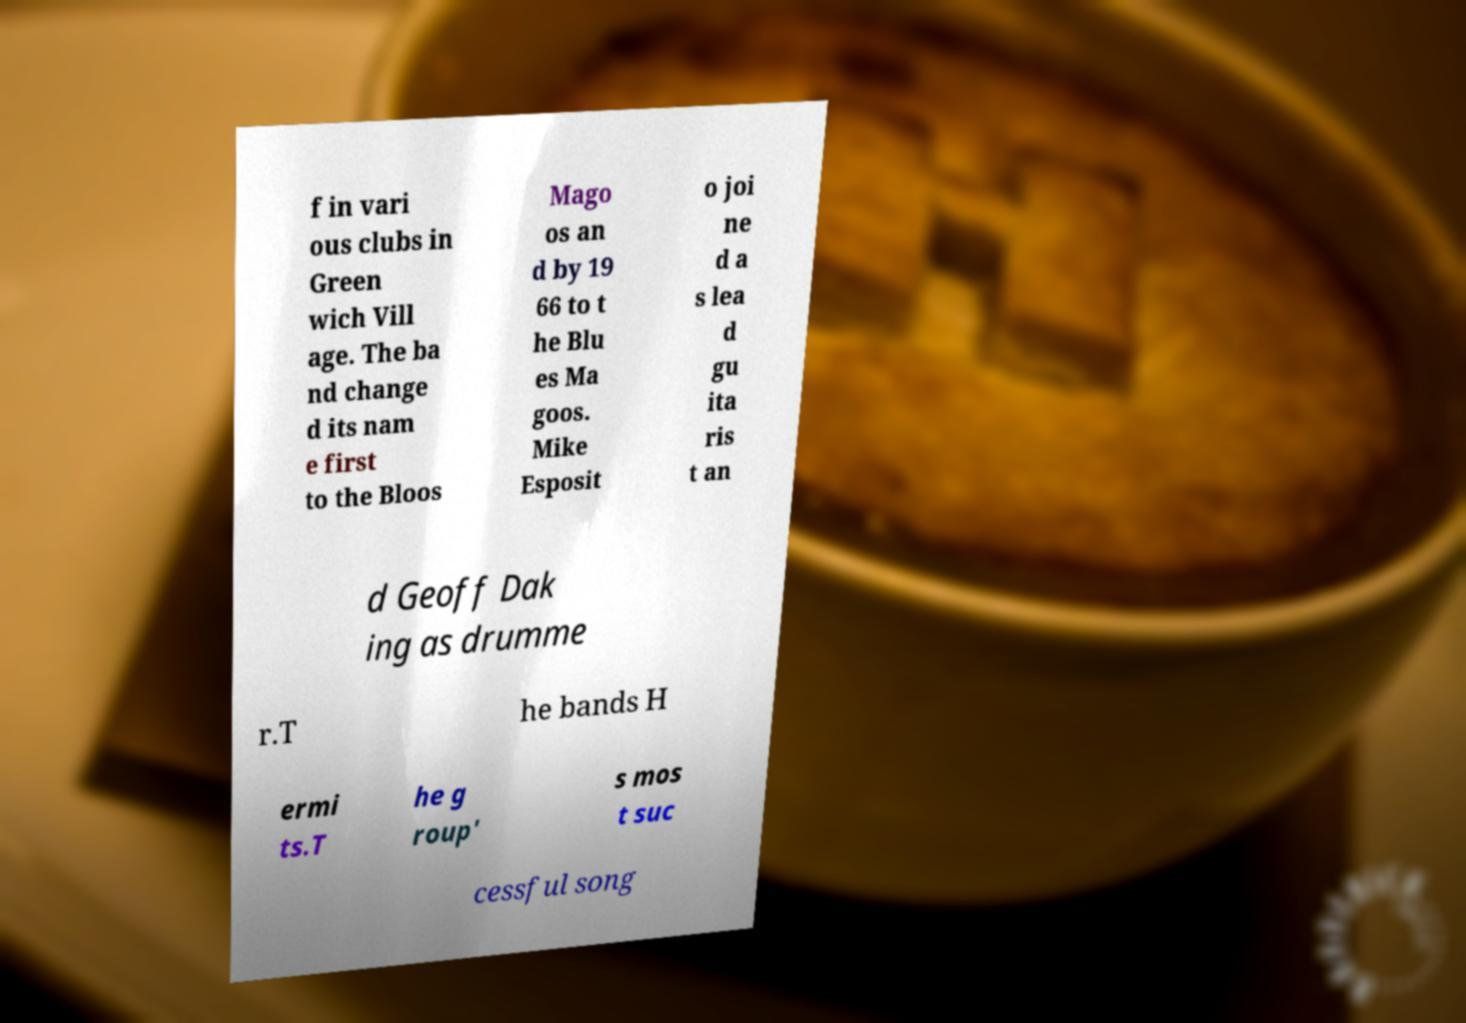There's text embedded in this image that I need extracted. Can you transcribe it verbatim? f in vari ous clubs in Green wich Vill age. The ba nd change d its nam e first to the Bloos Mago os an d by 19 66 to t he Blu es Ma goos. Mike Esposit o joi ne d a s lea d gu ita ris t an d Geoff Dak ing as drumme r.T he bands H ermi ts.T he g roup' s mos t suc cessful song 